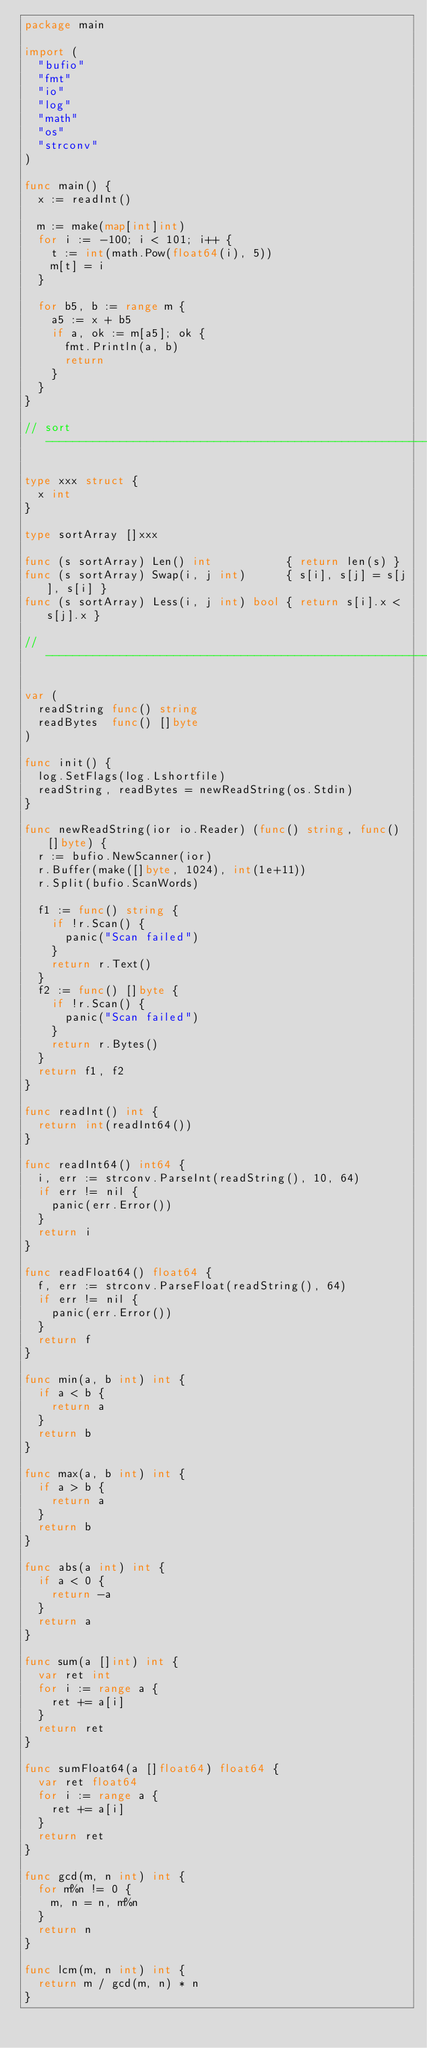Convert code to text. <code><loc_0><loc_0><loc_500><loc_500><_Go_>package main

import (
	"bufio"
	"fmt"
	"io"
	"log"
	"math"
	"os"
	"strconv"
)

func main() {
	x := readInt()

	m := make(map[int]int)
	for i := -100; i < 101; i++ {
		t := int(math.Pow(float64(i), 5))
		m[t] = i
	}

	for b5, b := range m {
		a5 := x + b5
		if a, ok := m[a5]; ok {
			fmt.Println(a, b)
			return
		}
	}
}

// sort ------------------------------------------------------------

type xxx struct {
	x int
}

type sortArray []xxx

func (s sortArray) Len() int           { return len(s) }
func (s sortArray) Swap(i, j int)      { s[i], s[j] = s[j], s[i] }
func (s sortArray) Less(i, j int) bool { return s[i].x < s[j].x }

// -----------------------------------------------------------------

var (
	readString func() string
	readBytes  func() []byte
)

func init() {
	log.SetFlags(log.Lshortfile)
	readString, readBytes = newReadString(os.Stdin)
}

func newReadString(ior io.Reader) (func() string, func() []byte) {
	r := bufio.NewScanner(ior)
	r.Buffer(make([]byte, 1024), int(1e+11))
	r.Split(bufio.ScanWords)

	f1 := func() string {
		if !r.Scan() {
			panic("Scan failed")
		}
		return r.Text()
	}
	f2 := func() []byte {
		if !r.Scan() {
			panic("Scan failed")
		}
		return r.Bytes()
	}
	return f1, f2
}

func readInt() int {
	return int(readInt64())
}

func readInt64() int64 {
	i, err := strconv.ParseInt(readString(), 10, 64)
	if err != nil {
		panic(err.Error())
	}
	return i
}

func readFloat64() float64 {
	f, err := strconv.ParseFloat(readString(), 64)
	if err != nil {
		panic(err.Error())
	}
	return f
}

func min(a, b int) int {
	if a < b {
		return a
	}
	return b
}

func max(a, b int) int {
	if a > b {
		return a
	}
	return b
}

func abs(a int) int {
	if a < 0 {
		return -a
	}
	return a
}

func sum(a []int) int {
	var ret int
	for i := range a {
		ret += a[i]
	}
	return ret
}

func sumFloat64(a []float64) float64 {
	var ret float64
	for i := range a {
		ret += a[i]
	}
	return ret
}

func gcd(m, n int) int {
	for m%n != 0 {
		m, n = n, m%n
	}
	return n
}

func lcm(m, n int) int {
	return m / gcd(m, n) * n
}
</code> 